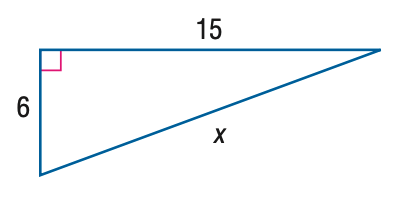Question: Find x.
Choices:
A. 3 \sqrt { 21 }
B. 3 \sqrt { 29 }
C. 17
D. 21
Answer with the letter. Answer: B 